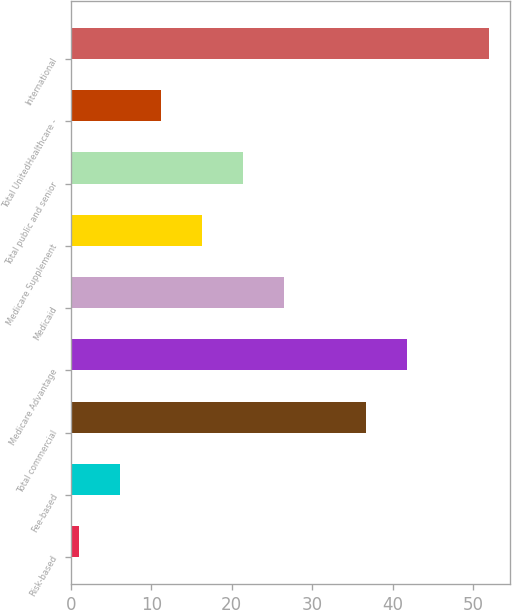Convert chart to OTSL. <chart><loc_0><loc_0><loc_500><loc_500><bar_chart><fcel>Risk-based<fcel>Fee-based<fcel>Total commercial<fcel>Medicare Advantage<fcel>Medicaid<fcel>Medicare Supplement<fcel>Total public and senior<fcel>Total UnitedHealthcare -<fcel>International<nl><fcel>1<fcel>6.1<fcel>36.7<fcel>41.8<fcel>26.5<fcel>16.3<fcel>21.4<fcel>11.2<fcel>52<nl></chart> 